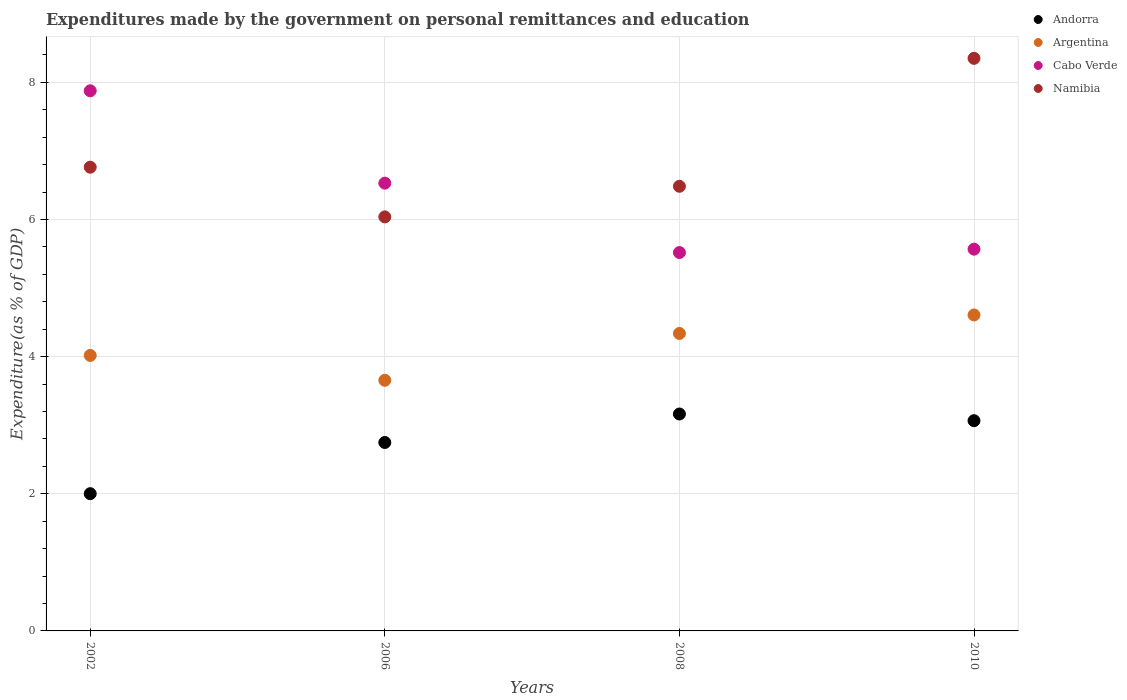How many different coloured dotlines are there?
Ensure brevity in your answer.  4. What is the expenditures made by the government on personal remittances and education in Andorra in 2002?
Ensure brevity in your answer.  2. Across all years, what is the maximum expenditures made by the government on personal remittances and education in Argentina?
Provide a short and direct response. 4.61. Across all years, what is the minimum expenditures made by the government on personal remittances and education in Andorra?
Offer a very short reply. 2. In which year was the expenditures made by the government on personal remittances and education in Argentina maximum?
Give a very brief answer. 2010. In which year was the expenditures made by the government on personal remittances and education in Namibia minimum?
Your response must be concise. 2006. What is the total expenditures made by the government on personal remittances and education in Namibia in the graph?
Ensure brevity in your answer.  27.63. What is the difference between the expenditures made by the government on personal remittances and education in Andorra in 2006 and that in 2010?
Provide a short and direct response. -0.32. What is the difference between the expenditures made by the government on personal remittances and education in Namibia in 2006 and the expenditures made by the government on personal remittances and education in Andorra in 2008?
Offer a very short reply. 2.87. What is the average expenditures made by the government on personal remittances and education in Cabo Verde per year?
Offer a very short reply. 6.37. In the year 2006, what is the difference between the expenditures made by the government on personal remittances and education in Argentina and expenditures made by the government on personal remittances and education in Namibia?
Offer a very short reply. -2.38. What is the ratio of the expenditures made by the government on personal remittances and education in Andorra in 2002 to that in 2008?
Your answer should be very brief. 0.63. Is the expenditures made by the government on personal remittances and education in Argentina in 2006 less than that in 2010?
Offer a very short reply. Yes. Is the difference between the expenditures made by the government on personal remittances and education in Argentina in 2002 and 2006 greater than the difference between the expenditures made by the government on personal remittances and education in Namibia in 2002 and 2006?
Keep it short and to the point. No. What is the difference between the highest and the second highest expenditures made by the government on personal remittances and education in Cabo Verde?
Ensure brevity in your answer.  1.35. What is the difference between the highest and the lowest expenditures made by the government on personal remittances and education in Argentina?
Provide a short and direct response. 0.95. Is the sum of the expenditures made by the government on personal remittances and education in Cabo Verde in 2006 and 2008 greater than the maximum expenditures made by the government on personal remittances and education in Andorra across all years?
Provide a short and direct response. Yes. Is it the case that in every year, the sum of the expenditures made by the government on personal remittances and education in Argentina and expenditures made by the government on personal remittances and education in Cabo Verde  is greater than the expenditures made by the government on personal remittances and education in Andorra?
Offer a very short reply. Yes. Is the expenditures made by the government on personal remittances and education in Argentina strictly less than the expenditures made by the government on personal remittances and education in Cabo Verde over the years?
Give a very brief answer. Yes. How many dotlines are there?
Provide a succinct answer. 4. What is the difference between two consecutive major ticks on the Y-axis?
Keep it short and to the point. 2. Are the values on the major ticks of Y-axis written in scientific E-notation?
Ensure brevity in your answer.  No. Does the graph contain any zero values?
Give a very brief answer. No. Does the graph contain grids?
Your response must be concise. Yes. How many legend labels are there?
Offer a very short reply. 4. What is the title of the graph?
Your answer should be compact. Expenditures made by the government on personal remittances and education. What is the label or title of the X-axis?
Your response must be concise. Years. What is the label or title of the Y-axis?
Offer a very short reply. Expenditure(as % of GDP). What is the Expenditure(as % of GDP) in Andorra in 2002?
Provide a short and direct response. 2. What is the Expenditure(as % of GDP) of Argentina in 2002?
Make the answer very short. 4.02. What is the Expenditure(as % of GDP) in Cabo Verde in 2002?
Offer a terse response. 7.88. What is the Expenditure(as % of GDP) in Namibia in 2002?
Offer a terse response. 6.76. What is the Expenditure(as % of GDP) of Andorra in 2006?
Give a very brief answer. 2.75. What is the Expenditure(as % of GDP) of Argentina in 2006?
Ensure brevity in your answer.  3.65. What is the Expenditure(as % of GDP) in Cabo Verde in 2006?
Provide a short and direct response. 6.53. What is the Expenditure(as % of GDP) of Namibia in 2006?
Give a very brief answer. 6.04. What is the Expenditure(as % of GDP) of Andorra in 2008?
Your response must be concise. 3.16. What is the Expenditure(as % of GDP) of Argentina in 2008?
Offer a very short reply. 4.34. What is the Expenditure(as % of GDP) of Cabo Verde in 2008?
Your answer should be compact. 5.52. What is the Expenditure(as % of GDP) of Namibia in 2008?
Your response must be concise. 6.48. What is the Expenditure(as % of GDP) in Andorra in 2010?
Your answer should be very brief. 3.07. What is the Expenditure(as % of GDP) in Argentina in 2010?
Your answer should be very brief. 4.61. What is the Expenditure(as % of GDP) in Cabo Verde in 2010?
Ensure brevity in your answer.  5.57. What is the Expenditure(as % of GDP) in Namibia in 2010?
Offer a terse response. 8.35. Across all years, what is the maximum Expenditure(as % of GDP) of Andorra?
Ensure brevity in your answer.  3.16. Across all years, what is the maximum Expenditure(as % of GDP) of Argentina?
Your response must be concise. 4.61. Across all years, what is the maximum Expenditure(as % of GDP) in Cabo Verde?
Provide a succinct answer. 7.88. Across all years, what is the maximum Expenditure(as % of GDP) in Namibia?
Offer a terse response. 8.35. Across all years, what is the minimum Expenditure(as % of GDP) in Andorra?
Give a very brief answer. 2. Across all years, what is the minimum Expenditure(as % of GDP) in Argentina?
Your answer should be compact. 3.65. Across all years, what is the minimum Expenditure(as % of GDP) of Cabo Verde?
Provide a short and direct response. 5.52. Across all years, what is the minimum Expenditure(as % of GDP) of Namibia?
Provide a succinct answer. 6.04. What is the total Expenditure(as % of GDP) in Andorra in the graph?
Ensure brevity in your answer.  10.98. What is the total Expenditure(as % of GDP) in Argentina in the graph?
Provide a succinct answer. 16.62. What is the total Expenditure(as % of GDP) of Cabo Verde in the graph?
Offer a very short reply. 25.49. What is the total Expenditure(as % of GDP) in Namibia in the graph?
Your response must be concise. 27.63. What is the difference between the Expenditure(as % of GDP) in Andorra in 2002 and that in 2006?
Provide a short and direct response. -0.75. What is the difference between the Expenditure(as % of GDP) in Argentina in 2002 and that in 2006?
Your answer should be very brief. 0.36. What is the difference between the Expenditure(as % of GDP) of Cabo Verde in 2002 and that in 2006?
Your answer should be very brief. 1.35. What is the difference between the Expenditure(as % of GDP) of Namibia in 2002 and that in 2006?
Keep it short and to the point. 0.72. What is the difference between the Expenditure(as % of GDP) in Andorra in 2002 and that in 2008?
Keep it short and to the point. -1.16. What is the difference between the Expenditure(as % of GDP) of Argentina in 2002 and that in 2008?
Offer a very short reply. -0.32. What is the difference between the Expenditure(as % of GDP) of Cabo Verde in 2002 and that in 2008?
Offer a very short reply. 2.36. What is the difference between the Expenditure(as % of GDP) of Namibia in 2002 and that in 2008?
Offer a terse response. 0.28. What is the difference between the Expenditure(as % of GDP) in Andorra in 2002 and that in 2010?
Your response must be concise. -1.06. What is the difference between the Expenditure(as % of GDP) in Argentina in 2002 and that in 2010?
Offer a terse response. -0.59. What is the difference between the Expenditure(as % of GDP) of Cabo Verde in 2002 and that in 2010?
Provide a short and direct response. 2.31. What is the difference between the Expenditure(as % of GDP) in Namibia in 2002 and that in 2010?
Ensure brevity in your answer.  -1.59. What is the difference between the Expenditure(as % of GDP) of Andorra in 2006 and that in 2008?
Provide a succinct answer. -0.42. What is the difference between the Expenditure(as % of GDP) of Argentina in 2006 and that in 2008?
Your response must be concise. -0.68. What is the difference between the Expenditure(as % of GDP) of Cabo Verde in 2006 and that in 2008?
Your response must be concise. 1.01. What is the difference between the Expenditure(as % of GDP) in Namibia in 2006 and that in 2008?
Offer a terse response. -0.45. What is the difference between the Expenditure(as % of GDP) of Andorra in 2006 and that in 2010?
Your response must be concise. -0.32. What is the difference between the Expenditure(as % of GDP) in Argentina in 2006 and that in 2010?
Offer a terse response. -0.95. What is the difference between the Expenditure(as % of GDP) in Cabo Verde in 2006 and that in 2010?
Make the answer very short. 0.96. What is the difference between the Expenditure(as % of GDP) of Namibia in 2006 and that in 2010?
Your answer should be compact. -2.31. What is the difference between the Expenditure(as % of GDP) of Andorra in 2008 and that in 2010?
Offer a terse response. 0.1. What is the difference between the Expenditure(as % of GDP) in Argentina in 2008 and that in 2010?
Ensure brevity in your answer.  -0.27. What is the difference between the Expenditure(as % of GDP) in Cabo Verde in 2008 and that in 2010?
Provide a succinct answer. -0.05. What is the difference between the Expenditure(as % of GDP) of Namibia in 2008 and that in 2010?
Provide a short and direct response. -1.87. What is the difference between the Expenditure(as % of GDP) in Andorra in 2002 and the Expenditure(as % of GDP) in Argentina in 2006?
Provide a short and direct response. -1.65. What is the difference between the Expenditure(as % of GDP) of Andorra in 2002 and the Expenditure(as % of GDP) of Cabo Verde in 2006?
Keep it short and to the point. -4.53. What is the difference between the Expenditure(as % of GDP) of Andorra in 2002 and the Expenditure(as % of GDP) of Namibia in 2006?
Ensure brevity in your answer.  -4.04. What is the difference between the Expenditure(as % of GDP) in Argentina in 2002 and the Expenditure(as % of GDP) in Cabo Verde in 2006?
Your answer should be compact. -2.51. What is the difference between the Expenditure(as % of GDP) in Argentina in 2002 and the Expenditure(as % of GDP) in Namibia in 2006?
Offer a terse response. -2.02. What is the difference between the Expenditure(as % of GDP) of Cabo Verde in 2002 and the Expenditure(as % of GDP) of Namibia in 2006?
Offer a terse response. 1.84. What is the difference between the Expenditure(as % of GDP) in Andorra in 2002 and the Expenditure(as % of GDP) in Argentina in 2008?
Your answer should be very brief. -2.34. What is the difference between the Expenditure(as % of GDP) in Andorra in 2002 and the Expenditure(as % of GDP) in Cabo Verde in 2008?
Offer a terse response. -3.52. What is the difference between the Expenditure(as % of GDP) of Andorra in 2002 and the Expenditure(as % of GDP) of Namibia in 2008?
Your response must be concise. -4.48. What is the difference between the Expenditure(as % of GDP) of Argentina in 2002 and the Expenditure(as % of GDP) of Cabo Verde in 2008?
Make the answer very short. -1.5. What is the difference between the Expenditure(as % of GDP) in Argentina in 2002 and the Expenditure(as % of GDP) in Namibia in 2008?
Ensure brevity in your answer.  -2.47. What is the difference between the Expenditure(as % of GDP) in Cabo Verde in 2002 and the Expenditure(as % of GDP) in Namibia in 2008?
Your response must be concise. 1.39. What is the difference between the Expenditure(as % of GDP) of Andorra in 2002 and the Expenditure(as % of GDP) of Argentina in 2010?
Your answer should be very brief. -2.61. What is the difference between the Expenditure(as % of GDP) of Andorra in 2002 and the Expenditure(as % of GDP) of Cabo Verde in 2010?
Your answer should be compact. -3.57. What is the difference between the Expenditure(as % of GDP) in Andorra in 2002 and the Expenditure(as % of GDP) in Namibia in 2010?
Offer a terse response. -6.35. What is the difference between the Expenditure(as % of GDP) in Argentina in 2002 and the Expenditure(as % of GDP) in Cabo Verde in 2010?
Give a very brief answer. -1.55. What is the difference between the Expenditure(as % of GDP) of Argentina in 2002 and the Expenditure(as % of GDP) of Namibia in 2010?
Provide a succinct answer. -4.33. What is the difference between the Expenditure(as % of GDP) of Cabo Verde in 2002 and the Expenditure(as % of GDP) of Namibia in 2010?
Offer a very short reply. -0.47. What is the difference between the Expenditure(as % of GDP) of Andorra in 2006 and the Expenditure(as % of GDP) of Argentina in 2008?
Your answer should be compact. -1.59. What is the difference between the Expenditure(as % of GDP) in Andorra in 2006 and the Expenditure(as % of GDP) in Cabo Verde in 2008?
Provide a short and direct response. -2.77. What is the difference between the Expenditure(as % of GDP) of Andorra in 2006 and the Expenditure(as % of GDP) of Namibia in 2008?
Provide a succinct answer. -3.74. What is the difference between the Expenditure(as % of GDP) of Argentina in 2006 and the Expenditure(as % of GDP) of Cabo Verde in 2008?
Provide a succinct answer. -1.86. What is the difference between the Expenditure(as % of GDP) in Argentina in 2006 and the Expenditure(as % of GDP) in Namibia in 2008?
Give a very brief answer. -2.83. What is the difference between the Expenditure(as % of GDP) in Cabo Verde in 2006 and the Expenditure(as % of GDP) in Namibia in 2008?
Your answer should be very brief. 0.05. What is the difference between the Expenditure(as % of GDP) of Andorra in 2006 and the Expenditure(as % of GDP) of Argentina in 2010?
Your answer should be very brief. -1.86. What is the difference between the Expenditure(as % of GDP) in Andorra in 2006 and the Expenditure(as % of GDP) in Cabo Verde in 2010?
Give a very brief answer. -2.82. What is the difference between the Expenditure(as % of GDP) in Andorra in 2006 and the Expenditure(as % of GDP) in Namibia in 2010?
Your answer should be very brief. -5.6. What is the difference between the Expenditure(as % of GDP) of Argentina in 2006 and the Expenditure(as % of GDP) of Cabo Verde in 2010?
Provide a short and direct response. -1.91. What is the difference between the Expenditure(as % of GDP) of Argentina in 2006 and the Expenditure(as % of GDP) of Namibia in 2010?
Your answer should be very brief. -4.69. What is the difference between the Expenditure(as % of GDP) in Cabo Verde in 2006 and the Expenditure(as % of GDP) in Namibia in 2010?
Your answer should be very brief. -1.82. What is the difference between the Expenditure(as % of GDP) in Andorra in 2008 and the Expenditure(as % of GDP) in Argentina in 2010?
Give a very brief answer. -1.44. What is the difference between the Expenditure(as % of GDP) in Andorra in 2008 and the Expenditure(as % of GDP) in Cabo Verde in 2010?
Your answer should be compact. -2.4. What is the difference between the Expenditure(as % of GDP) of Andorra in 2008 and the Expenditure(as % of GDP) of Namibia in 2010?
Provide a succinct answer. -5.19. What is the difference between the Expenditure(as % of GDP) in Argentina in 2008 and the Expenditure(as % of GDP) in Cabo Verde in 2010?
Your answer should be very brief. -1.23. What is the difference between the Expenditure(as % of GDP) of Argentina in 2008 and the Expenditure(as % of GDP) of Namibia in 2010?
Provide a short and direct response. -4.01. What is the difference between the Expenditure(as % of GDP) of Cabo Verde in 2008 and the Expenditure(as % of GDP) of Namibia in 2010?
Your response must be concise. -2.83. What is the average Expenditure(as % of GDP) of Andorra per year?
Offer a terse response. 2.74. What is the average Expenditure(as % of GDP) of Argentina per year?
Keep it short and to the point. 4.15. What is the average Expenditure(as % of GDP) in Cabo Verde per year?
Provide a succinct answer. 6.37. What is the average Expenditure(as % of GDP) in Namibia per year?
Ensure brevity in your answer.  6.91. In the year 2002, what is the difference between the Expenditure(as % of GDP) in Andorra and Expenditure(as % of GDP) in Argentina?
Your response must be concise. -2.02. In the year 2002, what is the difference between the Expenditure(as % of GDP) in Andorra and Expenditure(as % of GDP) in Cabo Verde?
Offer a terse response. -5.88. In the year 2002, what is the difference between the Expenditure(as % of GDP) in Andorra and Expenditure(as % of GDP) in Namibia?
Make the answer very short. -4.76. In the year 2002, what is the difference between the Expenditure(as % of GDP) of Argentina and Expenditure(as % of GDP) of Cabo Verde?
Make the answer very short. -3.86. In the year 2002, what is the difference between the Expenditure(as % of GDP) of Argentina and Expenditure(as % of GDP) of Namibia?
Your answer should be very brief. -2.75. In the year 2002, what is the difference between the Expenditure(as % of GDP) in Cabo Verde and Expenditure(as % of GDP) in Namibia?
Provide a succinct answer. 1.11. In the year 2006, what is the difference between the Expenditure(as % of GDP) of Andorra and Expenditure(as % of GDP) of Argentina?
Provide a succinct answer. -0.91. In the year 2006, what is the difference between the Expenditure(as % of GDP) in Andorra and Expenditure(as % of GDP) in Cabo Verde?
Your answer should be compact. -3.78. In the year 2006, what is the difference between the Expenditure(as % of GDP) in Andorra and Expenditure(as % of GDP) in Namibia?
Your response must be concise. -3.29. In the year 2006, what is the difference between the Expenditure(as % of GDP) in Argentina and Expenditure(as % of GDP) in Cabo Verde?
Keep it short and to the point. -2.87. In the year 2006, what is the difference between the Expenditure(as % of GDP) of Argentina and Expenditure(as % of GDP) of Namibia?
Offer a very short reply. -2.38. In the year 2006, what is the difference between the Expenditure(as % of GDP) in Cabo Verde and Expenditure(as % of GDP) in Namibia?
Your answer should be compact. 0.49. In the year 2008, what is the difference between the Expenditure(as % of GDP) in Andorra and Expenditure(as % of GDP) in Argentina?
Provide a succinct answer. -1.17. In the year 2008, what is the difference between the Expenditure(as % of GDP) of Andorra and Expenditure(as % of GDP) of Cabo Verde?
Make the answer very short. -2.35. In the year 2008, what is the difference between the Expenditure(as % of GDP) in Andorra and Expenditure(as % of GDP) in Namibia?
Keep it short and to the point. -3.32. In the year 2008, what is the difference between the Expenditure(as % of GDP) of Argentina and Expenditure(as % of GDP) of Cabo Verde?
Your response must be concise. -1.18. In the year 2008, what is the difference between the Expenditure(as % of GDP) of Argentina and Expenditure(as % of GDP) of Namibia?
Provide a short and direct response. -2.15. In the year 2008, what is the difference between the Expenditure(as % of GDP) in Cabo Verde and Expenditure(as % of GDP) in Namibia?
Your answer should be compact. -0.97. In the year 2010, what is the difference between the Expenditure(as % of GDP) of Andorra and Expenditure(as % of GDP) of Argentina?
Offer a terse response. -1.54. In the year 2010, what is the difference between the Expenditure(as % of GDP) of Andorra and Expenditure(as % of GDP) of Cabo Verde?
Keep it short and to the point. -2.5. In the year 2010, what is the difference between the Expenditure(as % of GDP) of Andorra and Expenditure(as % of GDP) of Namibia?
Make the answer very short. -5.28. In the year 2010, what is the difference between the Expenditure(as % of GDP) of Argentina and Expenditure(as % of GDP) of Cabo Verde?
Provide a short and direct response. -0.96. In the year 2010, what is the difference between the Expenditure(as % of GDP) of Argentina and Expenditure(as % of GDP) of Namibia?
Provide a short and direct response. -3.74. In the year 2010, what is the difference between the Expenditure(as % of GDP) of Cabo Verde and Expenditure(as % of GDP) of Namibia?
Ensure brevity in your answer.  -2.78. What is the ratio of the Expenditure(as % of GDP) in Andorra in 2002 to that in 2006?
Give a very brief answer. 0.73. What is the ratio of the Expenditure(as % of GDP) of Argentina in 2002 to that in 2006?
Your answer should be very brief. 1.1. What is the ratio of the Expenditure(as % of GDP) in Cabo Verde in 2002 to that in 2006?
Your response must be concise. 1.21. What is the ratio of the Expenditure(as % of GDP) in Namibia in 2002 to that in 2006?
Give a very brief answer. 1.12. What is the ratio of the Expenditure(as % of GDP) of Andorra in 2002 to that in 2008?
Offer a very short reply. 0.63. What is the ratio of the Expenditure(as % of GDP) of Argentina in 2002 to that in 2008?
Make the answer very short. 0.93. What is the ratio of the Expenditure(as % of GDP) of Cabo Verde in 2002 to that in 2008?
Provide a short and direct response. 1.43. What is the ratio of the Expenditure(as % of GDP) of Namibia in 2002 to that in 2008?
Keep it short and to the point. 1.04. What is the ratio of the Expenditure(as % of GDP) in Andorra in 2002 to that in 2010?
Your answer should be very brief. 0.65. What is the ratio of the Expenditure(as % of GDP) in Argentina in 2002 to that in 2010?
Offer a terse response. 0.87. What is the ratio of the Expenditure(as % of GDP) of Cabo Verde in 2002 to that in 2010?
Your answer should be compact. 1.41. What is the ratio of the Expenditure(as % of GDP) of Namibia in 2002 to that in 2010?
Provide a succinct answer. 0.81. What is the ratio of the Expenditure(as % of GDP) in Andorra in 2006 to that in 2008?
Offer a terse response. 0.87. What is the ratio of the Expenditure(as % of GDP) in Argentina in 2006 to that in 2008?
Provide a succinct answer. 0.84. What is the ratio of the Expenditure(as % of GDP) in Cabo Verde in 2006 to that in 2008?
Offer a terse response. 1.18. What is the ratio of the Expenditure(as % of GDP) of Namibia in 2006 to that in 2008?
Provide a succinct answer. 0.93. What is the ratio of the Expenditure(as % of GDP) in Andorra in 2006 to that in 2010?
Give a very brief answer. 0.9. What is the ratio of the Expenditure(as % of GDP) in Argentina in 2006 to that in 2010?
Your response must be concise. 0.79. What is the ratio of the Expenditure(as % of GDP) in Cabo Verde in 2006 to that in 2010?
Your answer should be compact. 1.17. What is the ratio of the Expenditure(as % of GDP) of Namibia in 2006 to that in 2010?
Provide a succinct answer. 0.72. What is the ratio of the Expenditure(as % of GDP) of Andorra in 2008 to that in 2010?
Keep it short and to the point. 1.03. What is the ratio of the Expenditure(as % of GDP) in Argentina in 2008 to that in 2010?
Your response must be concise. 0.94. What is the ratio of the Expenditure(as % of GDP) in Cabo Verde in 2008 to that in 2010?
Ensure brevity in your answer.  0.99. What is the ratio of the Expenditure(as % of GDP) of Namibia in 2008 to that in 2010?
Offer a terse response. 0.78. What is the difference between the highest and the second highest Expenditure(as % of GDP) of Andorra?
Your answer should be compact. 0.1. What is the difference between the highest and the second highest Expenditure(as % of GDP) of Argentina?
Keep it short and to the point. 0.27. What is the difference between the highest and the second highest Expenditure(as % of GDP) of Cabo Verde?
Offer a terse response. 1.35. What is the difference between the highest and the second highest Expenditure(as % of GDP) in Namibia?
Ensure brevity in your answer.  1.59. What is the difference between the highest and the lowest Expenditure(as % of GDP) of Andorra?
Your response must be concise. 1.16. What is the difference between the highest and the lowest Expenditure(as % of GDP) in Argentina?
Your answer should be very brief. 0.95. What is the difference between the highest and the lowest Expenditure(as % of GDP) of Cabo Verde?
Provide a short and direct response. 2.36. What is the difference between the highest and the lowest Expenditure(as % of GDP) in Namibia?
Make the answer very short. 2.31. 